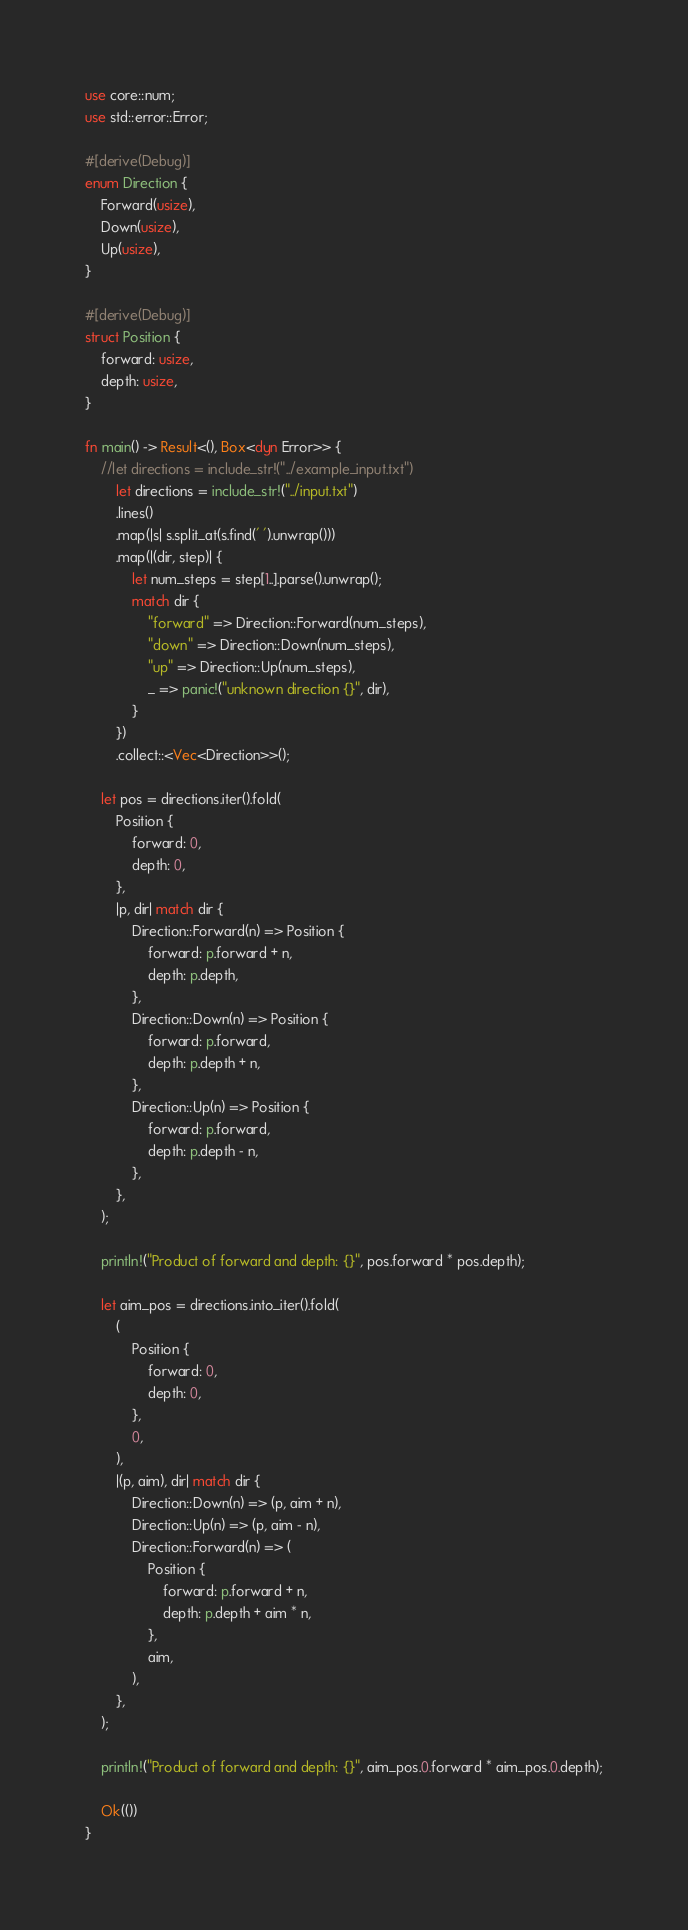<code> <loc_0><loc_0><loc_500><loc_500><_Rust_>use core::num;
use std::error::Error;

#[derive(Debug)]
enum Direction {
    Forward(usize),
    Down(usize),
    Up(usize),
}

#[derive(Debug)]
struct Position {
    forward: usize,
    depth: usize,
}

fn main() -> Result<(), Box<dyn Error>> {
    //let directions = include_str!("../example_input.txt")
        let directions = include_str!("../input.txt")
        .lines()
        .map(|s| s.split_at(s.find(' ').unwrap()))
        .map(|(dir, step)| {
            let num_steps = step[1..].parse().unwrap();
            match dir {
                "forward" => Direction::Forward(num_steps),
                "down" => Direction::Down(num_steps),
                "up" => Direction::Up(num_steps),
                _ => panic!("unknown direction {}", dir),
            }
        })
        .collect::<Vec<Direction>>();

    let pos = directions.iter().fold(
        Position {
            forward: 0,
            depth: 0,
        },
        |p, dir| match dir {
            Direction::Forward(n) => Position {
                forward: p.forward + n,
                depth: p.depth,
            },
            Direction::Down(n) => Position {
                forward: p.forward,
                depth: p.depth + n,
            },
            Direction::Up(n) => Position {
                forward: p.forward,
                depth: p.depth - n,
            },
        },
    );

    println!("Product of forward and depth: {}", pos.forward * pos.depth);

    let aim_pos = directions.into_iter().fold(
        (
            Position {
                forward: 0,
                depth: 0,
            },
            0,
        ),
        |(p, aim), dir| match dir {
            Direction::Down(n) => (p, aim + n),
            Direction::Up(n) => (p, aim - n),
            Direction::Forward(n) => (
                Position {
                    forward: p.forward + n,
                    depth: p.depth + aim * n,
                },
                aim,
            ),
        },
    );

    println!("Product of forward and depth: {}", aim_pos.0.forward * aim_pos.0.depth);

    Ok(())
}
</code> 